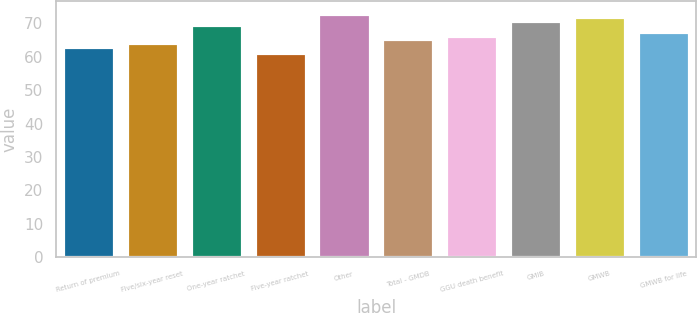Convert chart to OTSL. <chart><loc_0><loc_0><loc_500><loc_500><bar_chart><fcel>Return of premium<fcel>Five/six-year reset<fcel>One-year ratchet<fcel>Five-year ratchet<fcel>Other<fcel>Total - GMDB<fcel>GGU death benefit<fcel>GMIB<fcel>GMWB<fcel>GMWB for life<nl><fcel>63<fcel>64.1<fcel>69.6<fcel>61<fcel>72.9<fcel>65.2<fcel>66.3<fcel>70.7<fcel>71.8<fcel>67.4<nl></chart> 